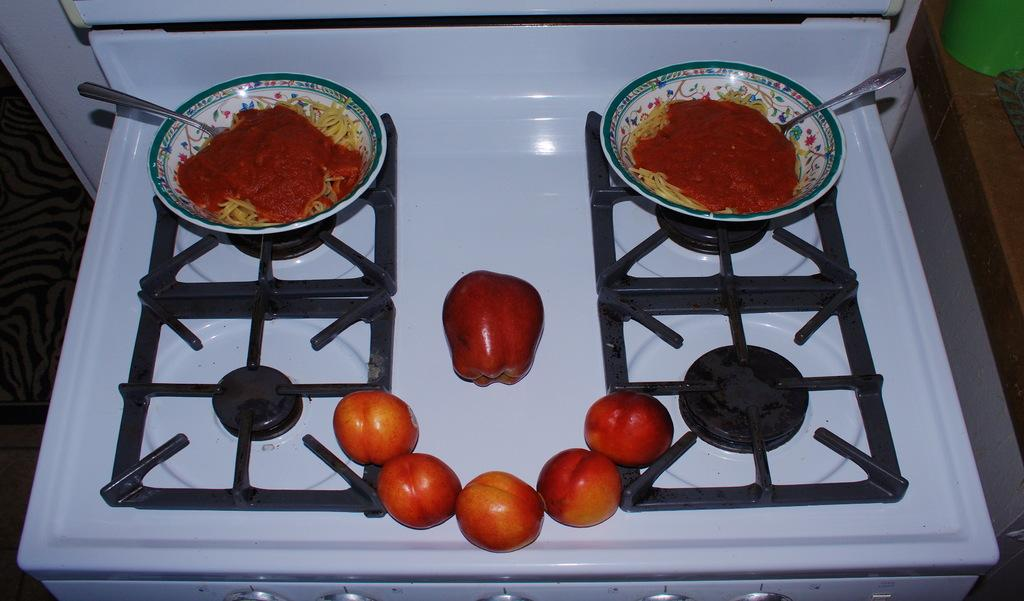What can be seen in the two bowls in the image? There are food items in the two bowls in the image. What utensils are present in the image? Spoons are present in the image. Where are the spoons placed in the image? The spoons are kept on a stove. What type of fruit is visible in the image? Apples are visible in the image. What part of the room can be seen in the image? The floor is visible in the image. What advice does the grandfather give to the robin in the image? There is no grandfather or robin present in the image. What mathematical operation is being performed with the apples in the image? There is no addition or any other mathematical operation being performed with the apples in the image. 